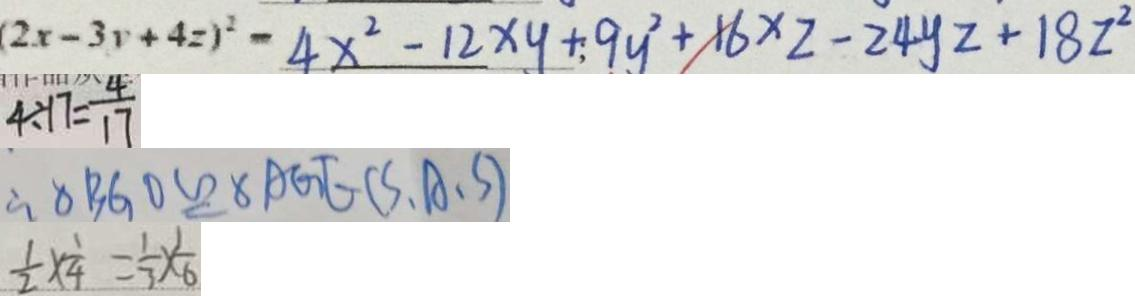Convert formula to latex. <formula><loc_0><loc_0><loc_500><loc_500>( 2 x - 3 y + 4 z ) ^ { 2 } - 4 x ^ { 2 } - 1 2 x y + 9 y ^ { 2 } + 1 6 x z - 2 4 y z + 1 8 z ^ { 2 } 
 4 \div 1 7 = \frac { 4 } { 1 7 } 
 \therefore \Delta B G O \cong \Delta A G E ( S . A . S ) 
 \frac { 1 } { 2 } \times \frac { 1 } { 4 } = \frac { 1 } { 3 } \times \frac { 1 } { 6 }</formula> 